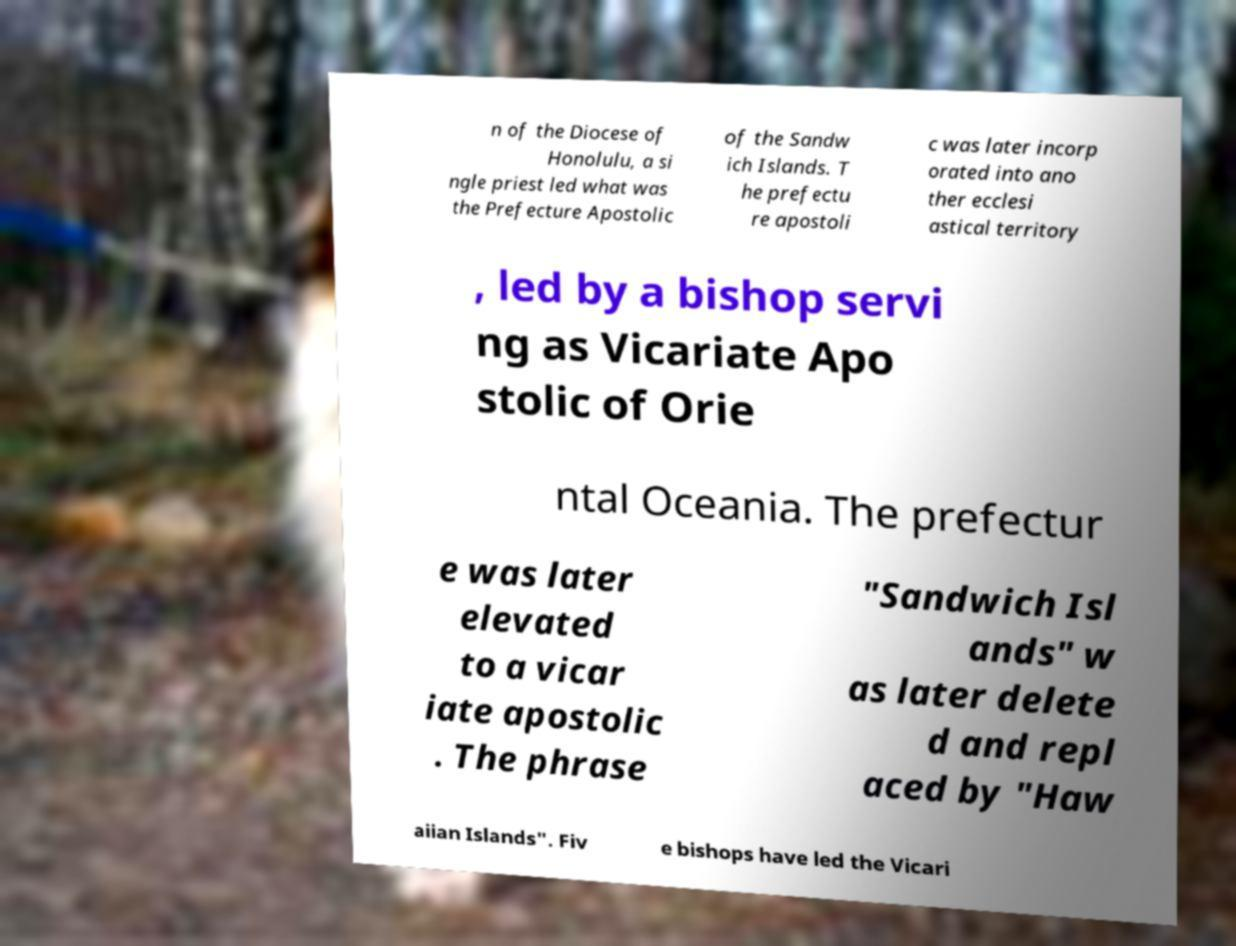Can you read and provide the text displayed in the image?This photo seems to have some interesting text. Can you extract and type it out for me? n of the Diocese of Honolulu, a si ngle priest led what was the Prefecture Apostolic of the Sandw ich Islands. T he prefectu re apostoli c was later incorp orated into ano ther ecclesi astical territory , led by a bishop servi ng as Vicariate Apo stolic of Orie ntal Oceania. The prefectur e was later elevated to a vicar iate apostolic . The phrase "Sandwich Isl ands" w as later delete d and repl aced by "Haw aiian Islands". Fiv e bishops have led the Vicari 